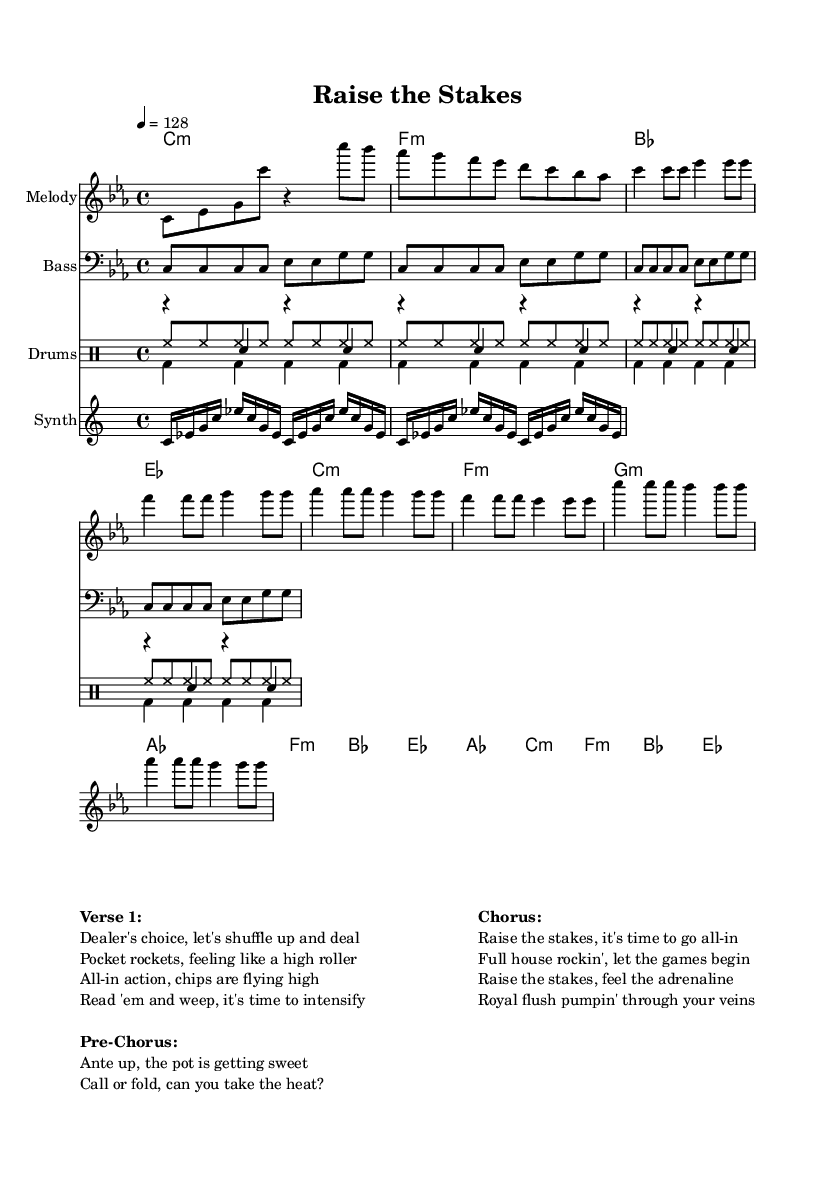What is the key signature of this music? The key signature is C minor, which contains three flats: B flat, E flat, and A flat. This is indicated in the key signature section at the beginning of the sheet music.
Answer: C minor What is the time signature of this music? The time signature is found at the beginning of the sheet music and is noted as 4/4, which means there are four beats in a measure and the quarter note gets one beat.
Answer: 4/4 What is the tempo marking for this piece? The tempo marking is indicated in the score as "4 = 128," which means there are 128 beats per minute, suggesting a moderate to fast pace suitable for dance music.
Answer: 128 What is the main theme of the chorus? The chorus emphasizes themes of stakes and excitement in gambling, evidenced by phrases like "Raise the stakes" and "Royal flush pumpin' through your veins," showcasing the energetic aspect of its dance genre.
Answer: Raise the stakes How many measures are in the chorus section? The chorus is structured with four measures based on the notation, each comprising a combination of quarter and eighth notes, totaling four lines of lyrics, confirming four measures overall.
Answer: 4 What type of dance-oriented rhythms are present in the drum section? The drum section includes a kick pattern, snare hits, and continuous hi-hat eighth notes, which is a characteristic of dance music, providing a steady and driving rhythmic foundation for the track.
Answer: Steady In which section does the phrase "Ante up, the pot is getting sweet" occur? This phrase is located in the Pre-Chorus section, serving as a transition to escalate the energy before leading into the chorus, highlighting the gambling theme prominent in the lyrics.
Answer: Pre-Chorus 